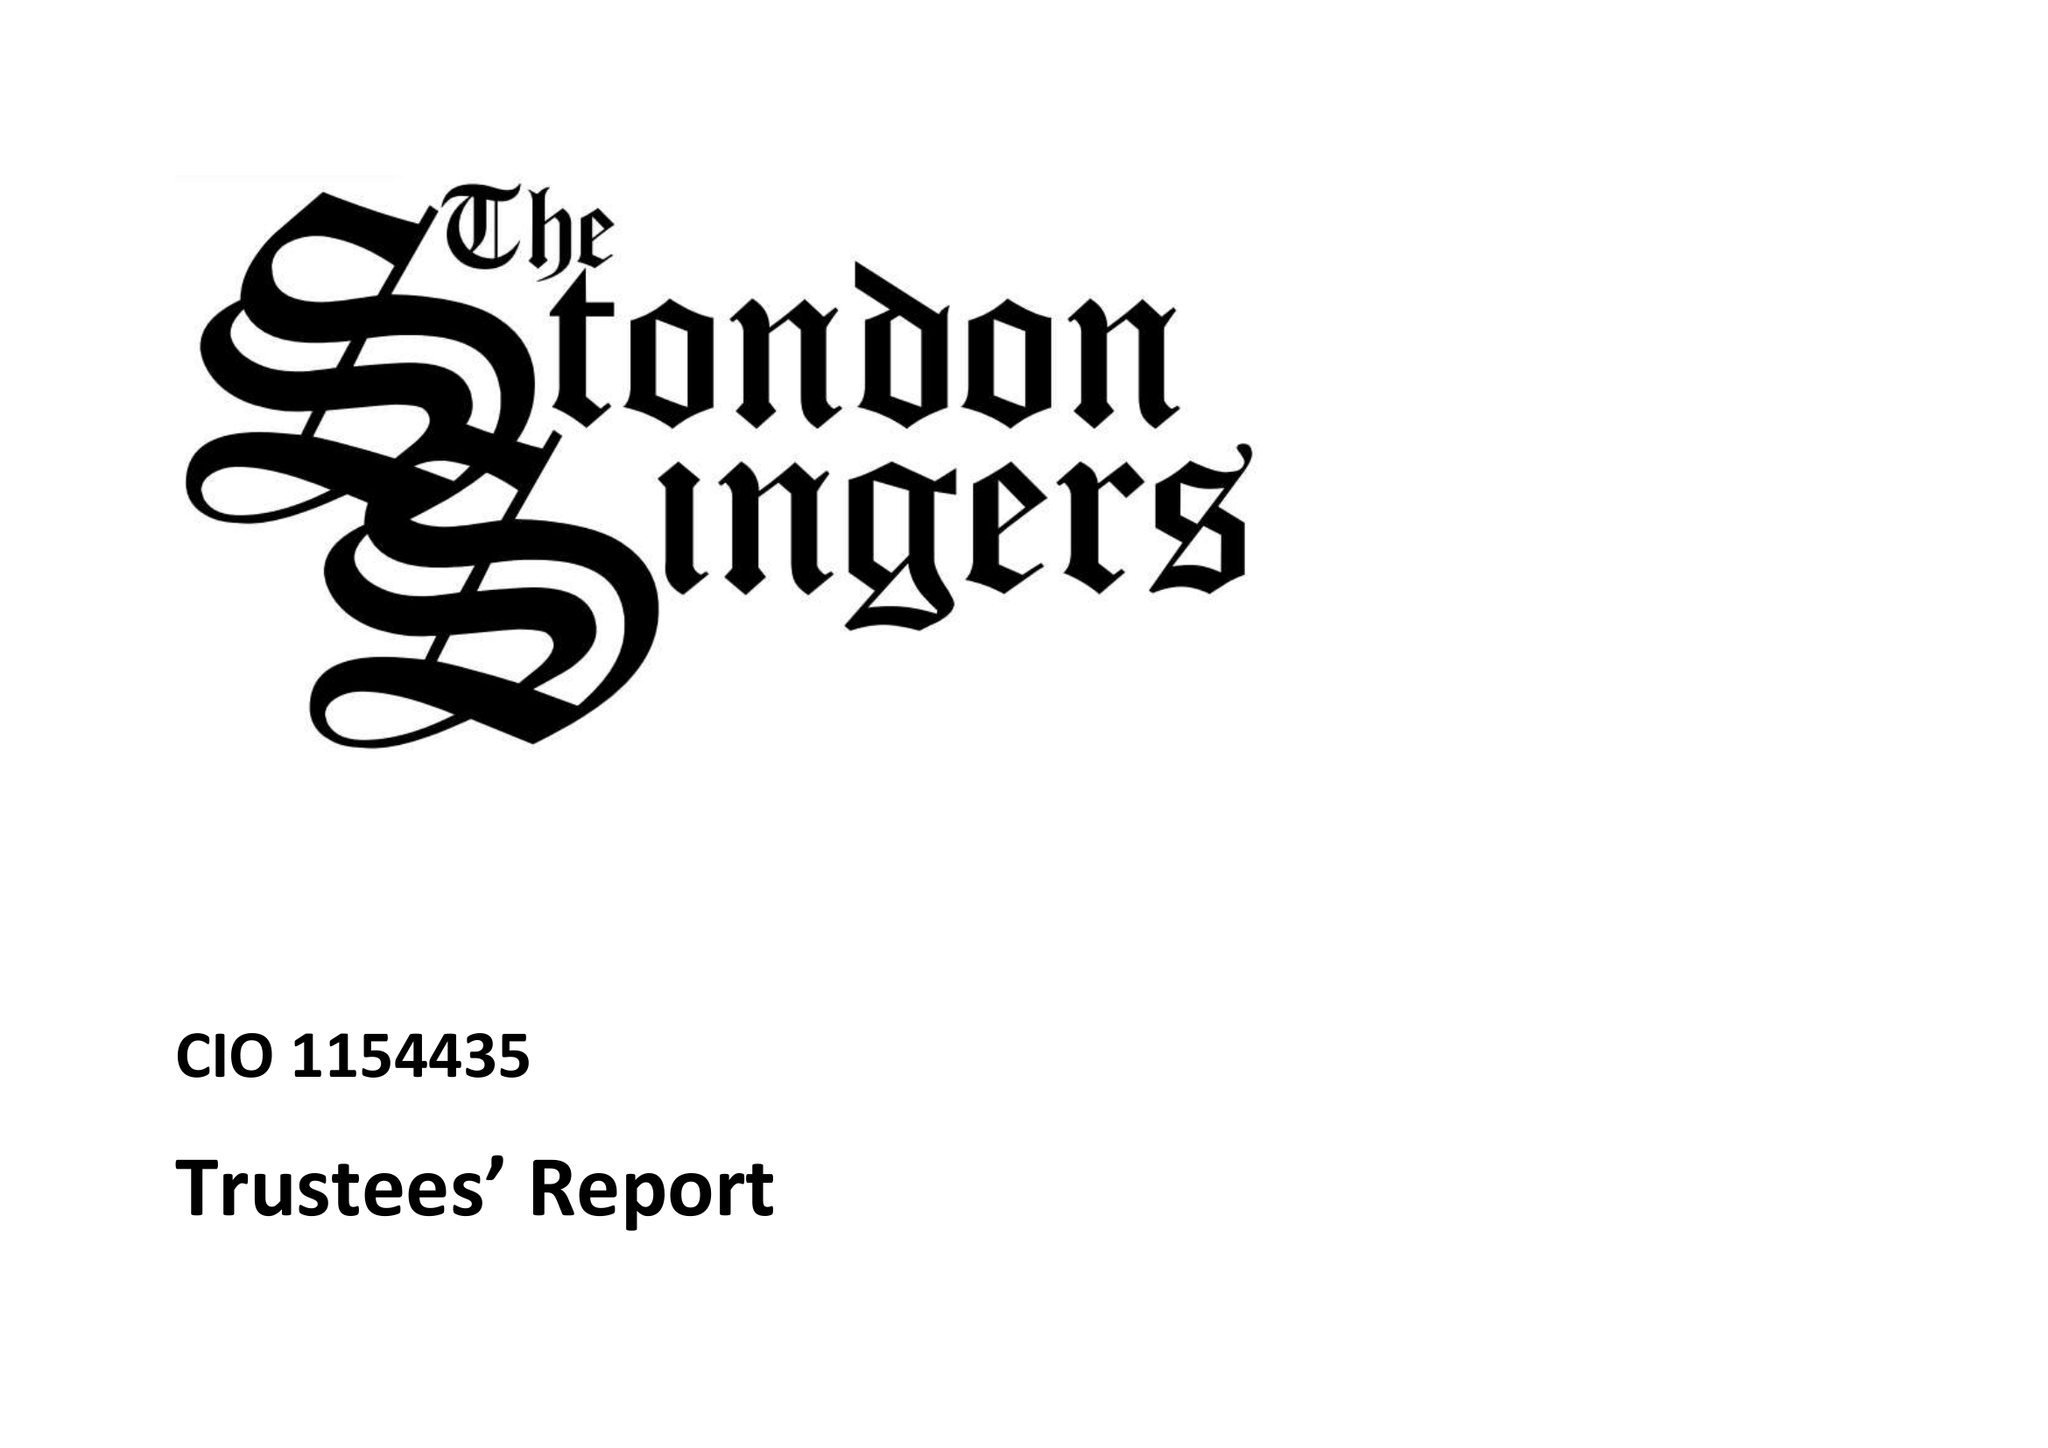What is the value for the address__postcode?
Answer the question using a single word or phrase. CM14 5QP 